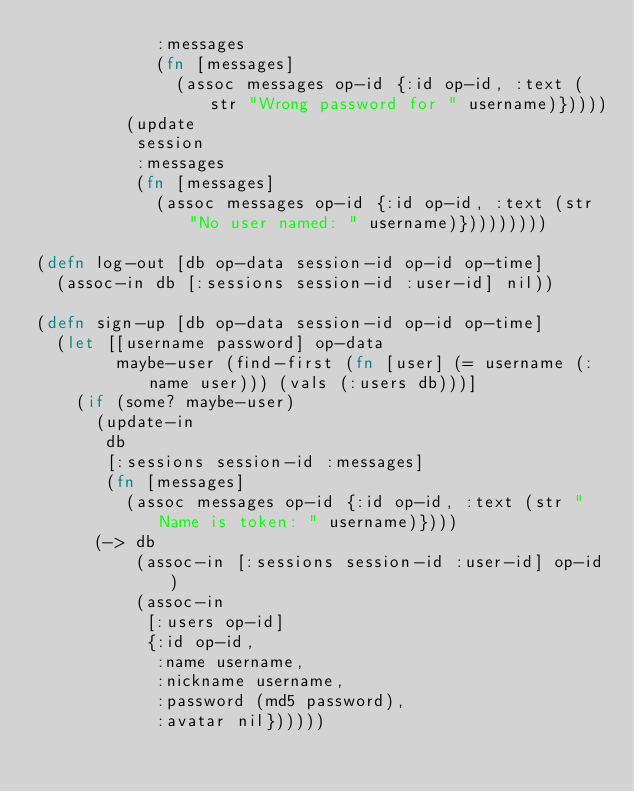<code> <loc_0><loc_0><loc_500><loc_500><_Clojure_>            :messages
            (fn [messages]
              (assoc messages op-id {:id op-id, :text (str "Wrong password for " username)}))))
         (update
          session
          :messages
          (fn [messages]
            (assoc messages op-id {:id op-id, :text (str "No user named: " username)}))))))))

(defn log-out [db op-data session-id op-id op-time]
  (assoc-in db [:sessions session-id :user-id] nil))

(defn sign-up [db op-data session-id op-id op-time]
  (let [[username password] op-data
        maybe-user (find-first (fn [user] (= username (:name user))) (vals (:users db)))]
    (if (some? maybe-user)
      (update-in
       db
       [:sessions session-id :messages]
       (fn [messages]
         (assoc messages op-id {:id op-id, :text (str "Name is token: " username)})))
      (-> db
          (assoc-in [:sessions session-id :user-id] op-id)
          (assoc-in
           [:users op-id]
           {:id op-id,
            :name username,
            :nickname username,
            :password (md5 password),
            :avatar nil})))))
</code> 